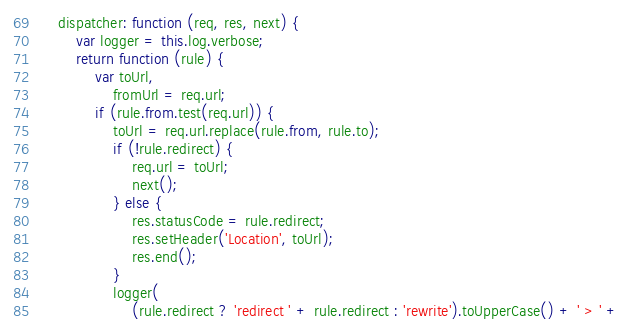Convert code to text. <code><loc_0><loc_0><loc_500><loc_500><_JavaScript_>
    dispatcher: function (req, res, next) {
        var logger = this.log.verbose;
        return function (rule) {
            var toUrl,
                fromUrl = req.url;
            if (rule.from.test(req.url)) {
                toUrl = req.url.replace(rule.from, rule.to);
                if (!rule.redirect) {
                    req.url = toUrl;
                    next();
                } else {
                    res.statusCode = rule.redirect;
                    res.setHeader('Location', toUrl);
                    res.end();
                }
                logger(
                    (rule.redirect ? 'redirect ' + rule.redirect : 'rewrite').toUpperCase() + ' > ' +</code> 